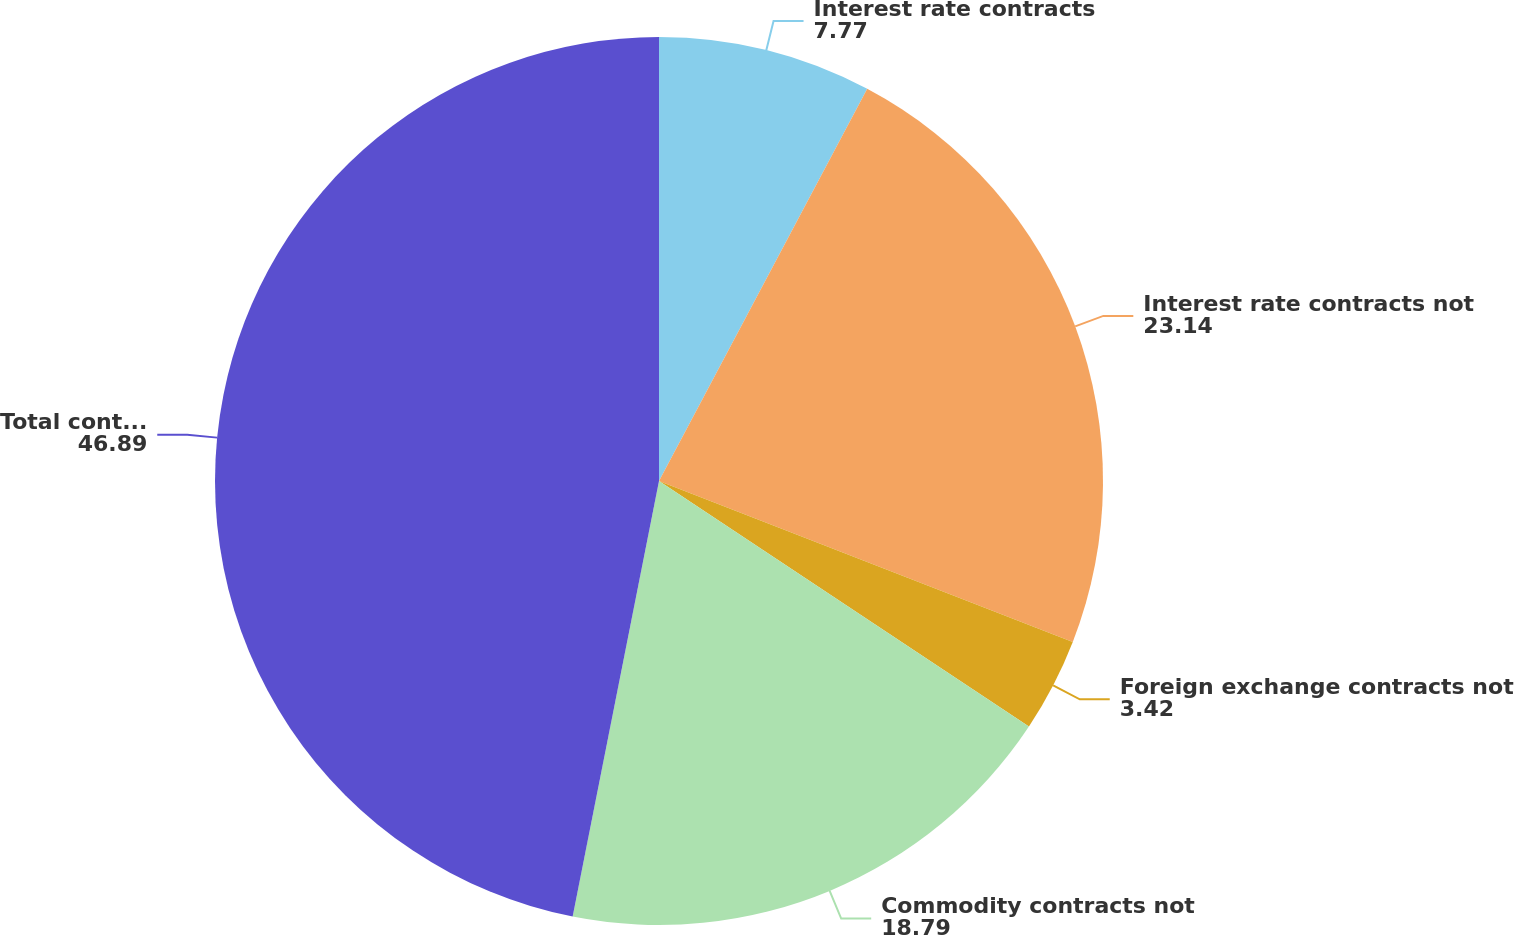<chart> <loc_0><loc_0><loc_500><loc_500><pie_chart><fcel>Interest rate contracts<fcel>Interest rate contracts not<fcel>Foreign exchange contracts not<fcel>Commodity contracts not<fcel>Total contracts<nl><fcel>7.77%<fcel>23.14%<fcel>3.42%<fcel>18.79%<fcel>46.89%<nl></chart> 